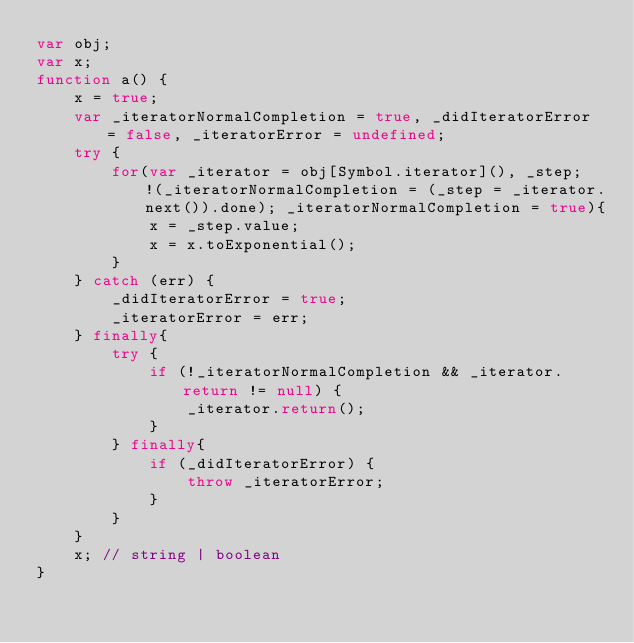<code> <loc_0><loc_0><loc_500><loc_500><_JavaScript_>var obj;
var x;
function a() {
    x = true;
    var _iteratorNormalCompletion = true, _didIteratorError = false, _iteratorError = undefined;
    try {
        for(var _iterator = obj[Symbol.iterator](), _step; !(_iteratorNormalCompletion = (_step = _iterator.next()).done); _iteratorNormalCompletion = true){
            x = _step.value;
            x = x.toExponential();
        }
    } catch (err) {
        _didIteratorError = true;
        _iteratorError = err;
    } finally{
        try {
            if (!_iteratorNormalCompletion && _iterator.return != null) {
                _iterator.return();
            }
        } finally{
            if (_didIteratorError) {
                throw _iteratorError;
            }
        }
    }
    x; // string | boolean
}
</code> 